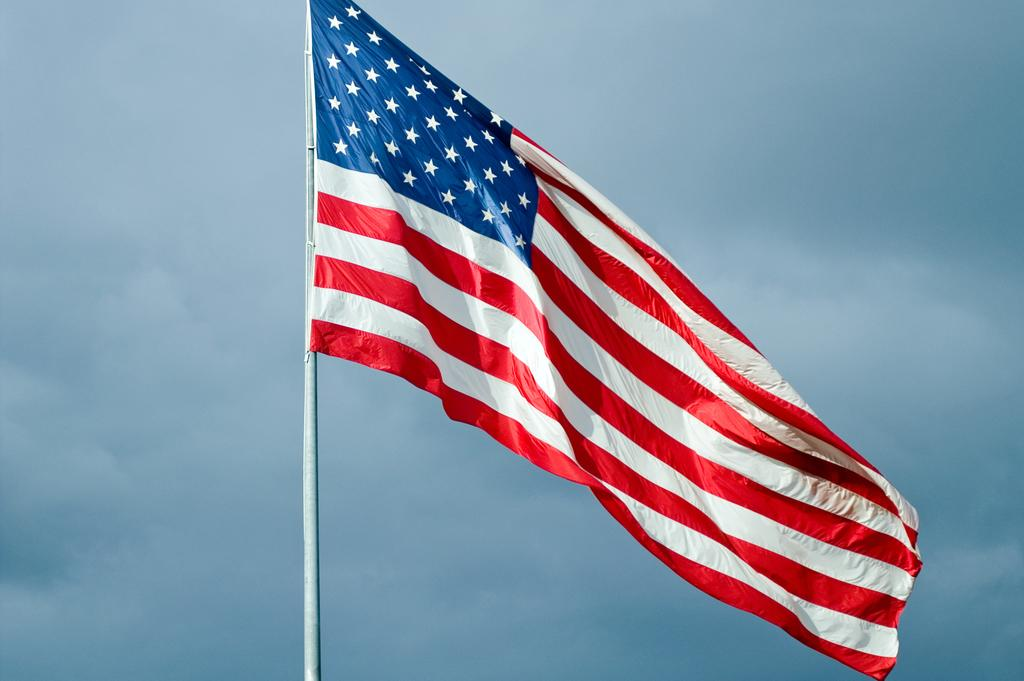What is attached to the pole in the image? There is a flag attached to the pole in the image. What can be seen in the background of the image? The sky is visible in the background of the image. How would you describe the sky in the image? The sky appears to be cloudy in the image. How many clocks are hanging from the flag in the image? There are no clocks present in the image; it only features a flag on a pole. What type of pest can be seen crawling on the flag in the image? There are no pests visible in the image, as it only shows a flag on a pole with a cloudy sky in the background. 